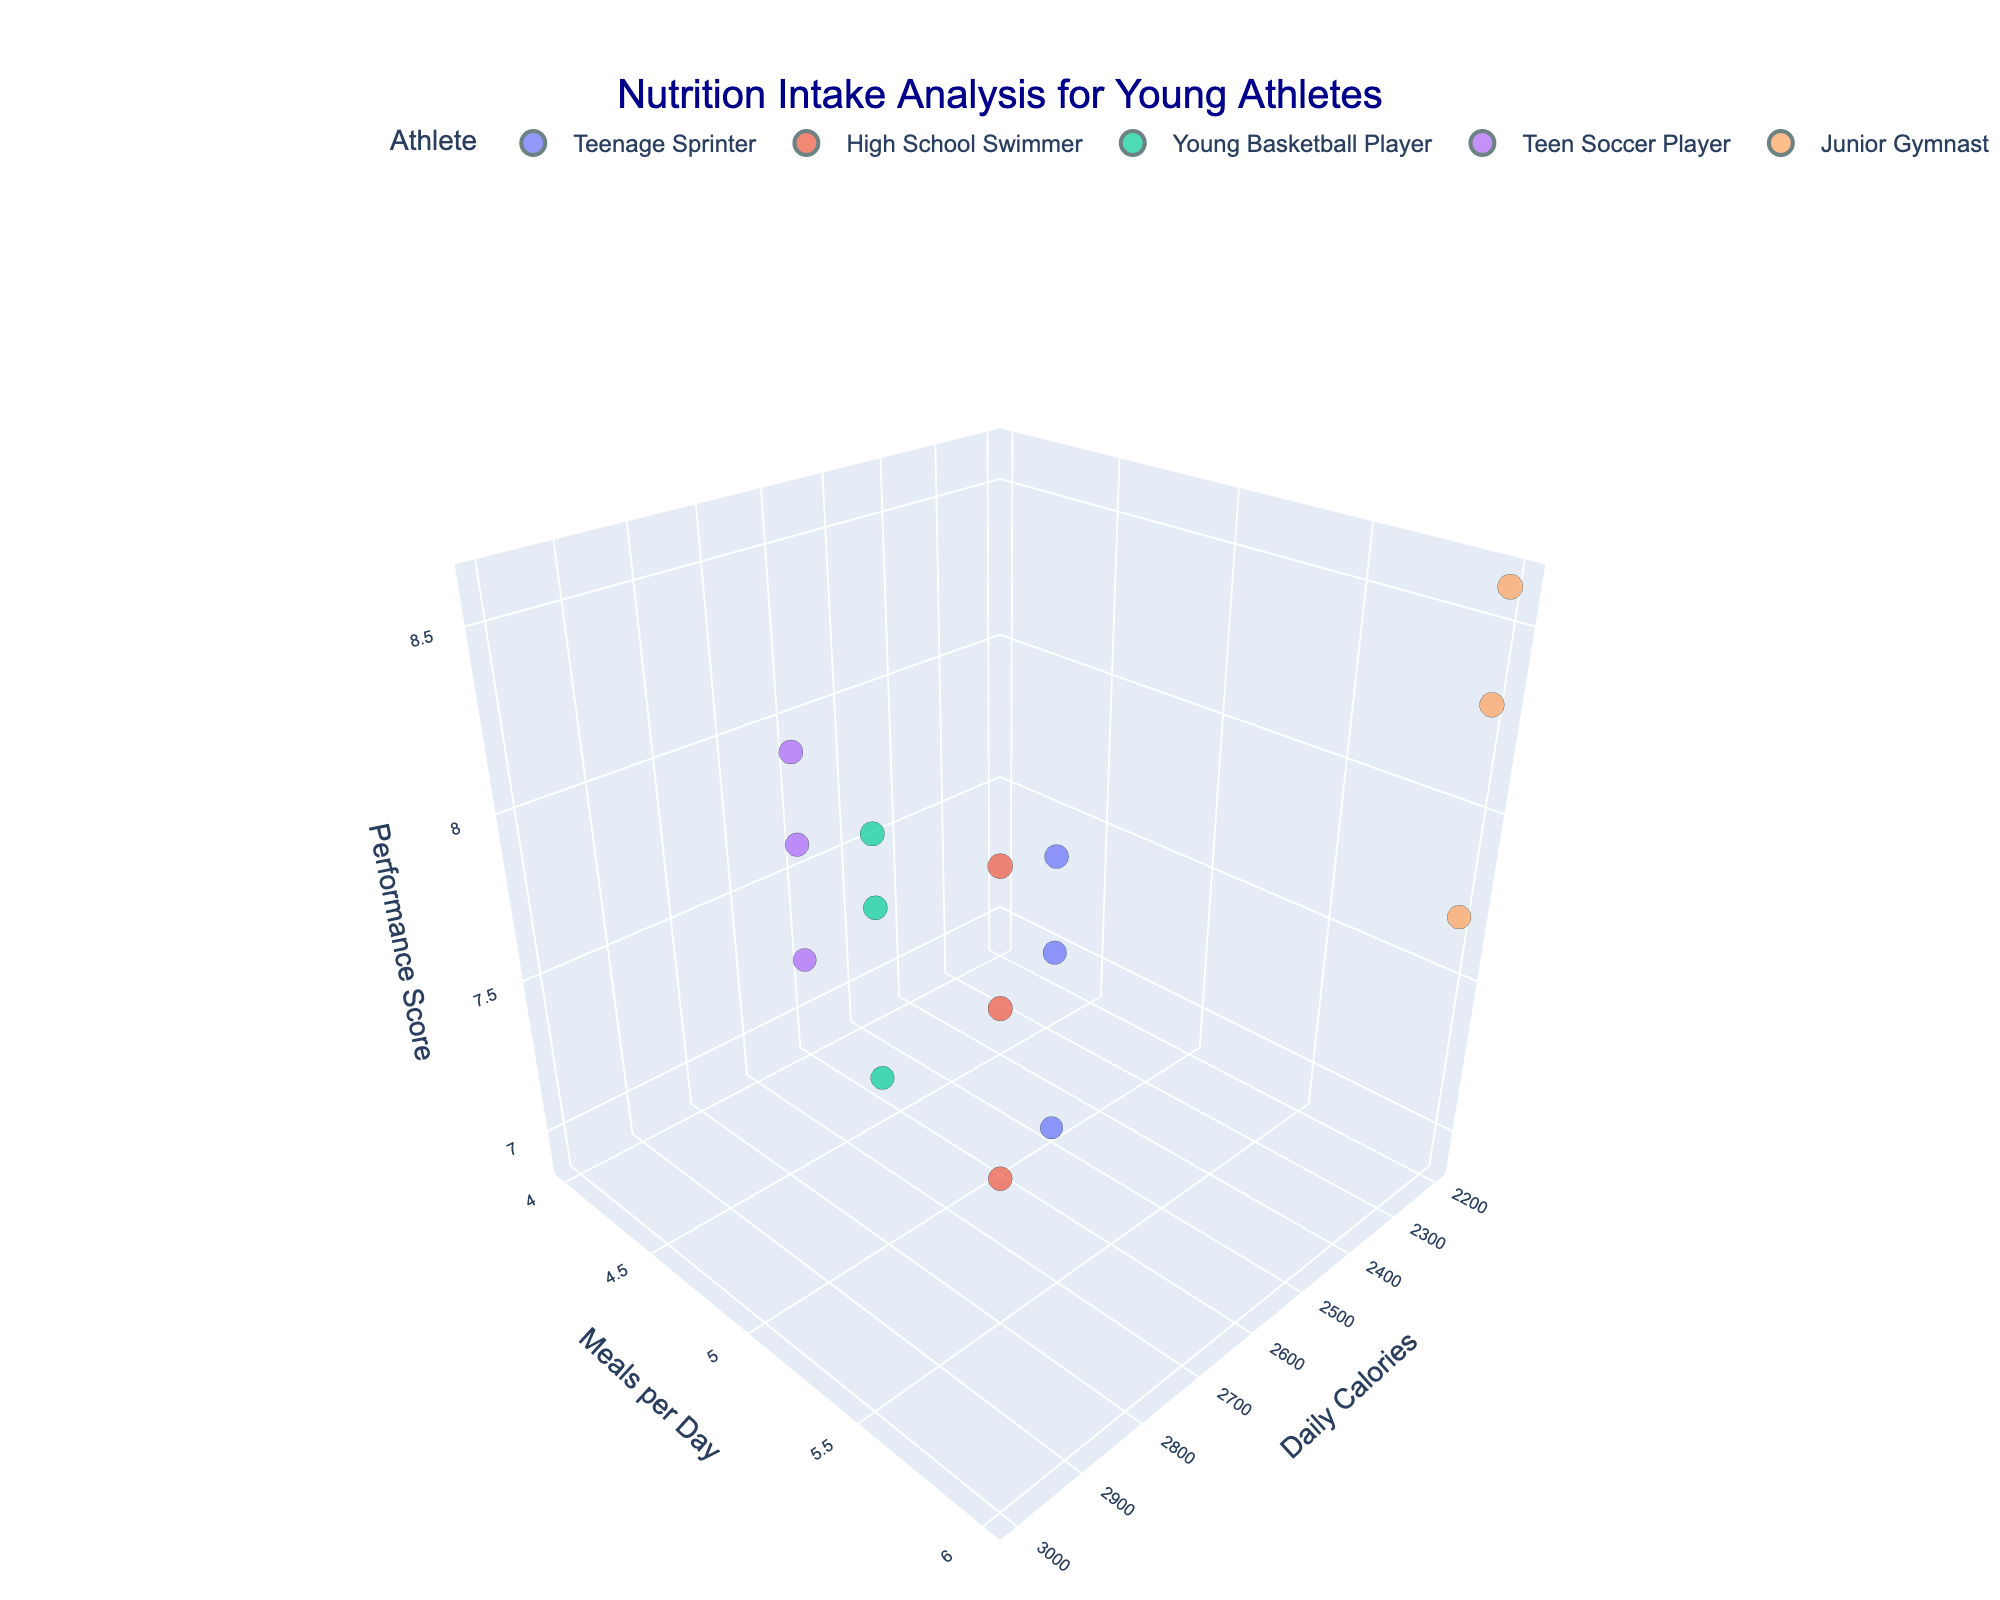What is the title of the figure? The title is written at the top center of the figure. The title text is "Nutrition Intake Analysis for Young Athletes".
Answer: Nutrition Intake Analysis for Young Athletes Which athlete appears to have data points with the highest performance score? By looking at the z-axis (Performance Score), we can identify the athlete with the highest value. The Junior Gymnast has the highest values reaching 8.6.
Answer: Junior Gymnast How does meal frequency relate to performance for the Young Basketball Player? Locate the Young Basketball Player data points, observe the y-axis (Meals per Day) and z-axis (Performance Score). Notice that they consume 5 meals per day with performance scores around 8.1.
Answer: Performance is around 8.1 with 5 meals per day Which macronutrient for the Teenage Sprinter correlates with the lowest performance score? Look at the Teenage Sprinter's data points, then compare the performance scores (z-axis) for Carbohydrates, Protein, and Fats. The lowest score, 6.9, corresponds to Fats.
Answer: Fats Who has more meals per day: the Teenage Sprinter or the Teen Soccer Player? Compare the meal frequency values (y-axis) of the two athletes. The Teenage Sprinter has 5 meals, and the Teen Soccer Player has 4 meals per day.
Answer: Teenage Sprinter If the High School Swimmer and Junior Gymnast both increase their meal frequency by one, who would likely have a higher performance score? Adding one to their current meal frequency will have the High School Swimmer at 7 meals and Junior Gymnast at 7 meals. Compare their performance scores to determine the higher value between these two points. The Junior Gymnast has a higher performance (8.6) compared to the High School Swimmer (8.5 for Protein).
Answer: Junior Gymnast What is the performance range for the Junior Gymnast? Look at all the performance values (z-axis) for Junior Gymnast. The lowest value is 7.7 and the highest is 8.6, so the range is from 7.7 to 8.6.
Answer: 7.7 to 8.6 Between Carbohydrates and Fats, which macronutrient leads to higher performance for the Junior Gymnast? Compare the performance scores (z-axis) for Carbohydrates and Fats for the Junior Gymnast. Carbohydrates have a higher score (8.3) compared to Fats (7.7).
Answer: Carbohydrates How does the calorie intake compare between the Teenage Sprinter and the Teen Soccer Player? Check the x-axis (Calories) values for Teenage Sprinter and Teen Soccer Player. Both athletes have a calorie intake of 2500 and 2600 respectively.
Answer: Teen Soccer Player has a higher calorie intake What is the combined performance score of the High School Swimmer for carbohydrates and fats? Locate the High School Swimmer's data points and sum the performance scores for Carbohydrates (8.2) and Fats (7.8). The combined score is 8.2 + 7.8.
Answer: 16.0 